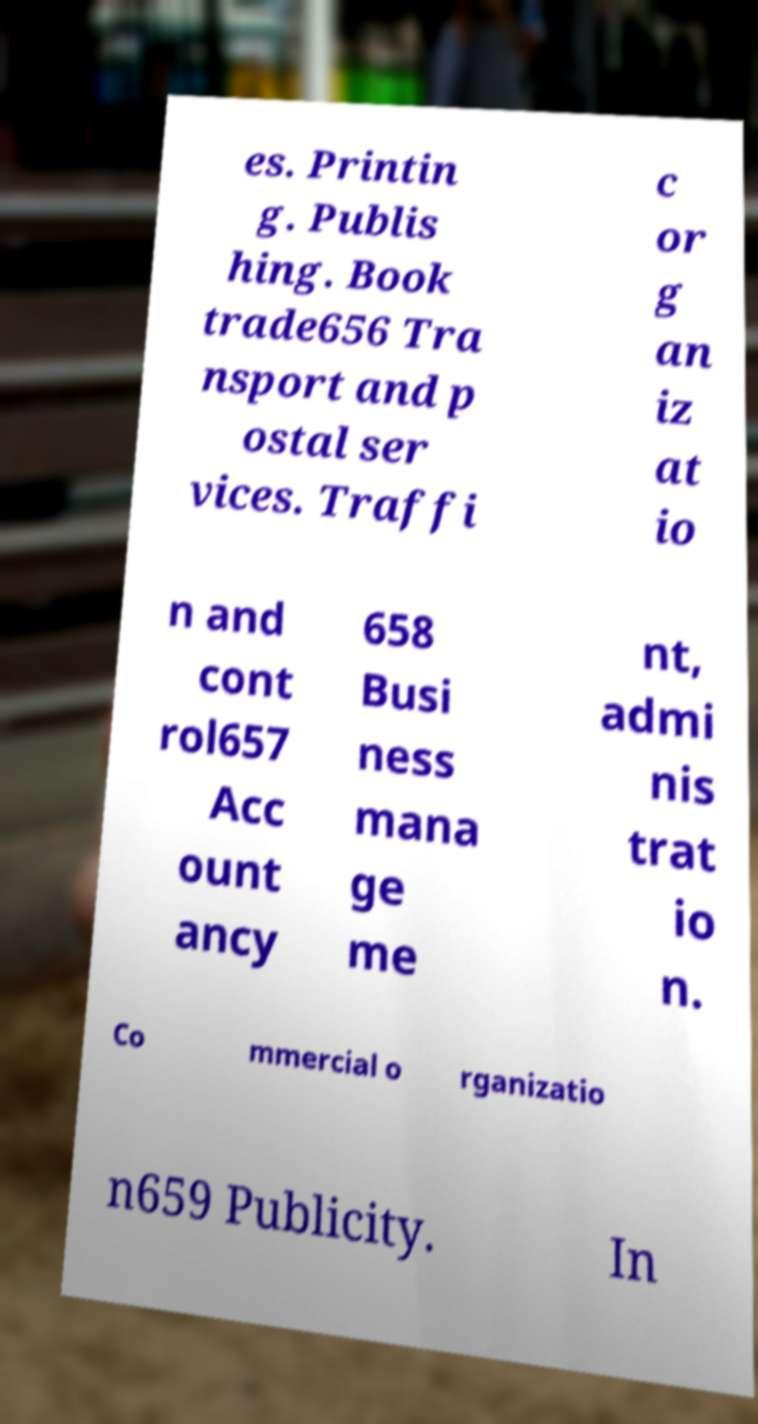Could you extract and type out the text from this image? es. Printin g. Publis hing. Book trade656 Tra nsport and p ostal ser vices. Traffi c or g an iz at io n and cont rol657 Acc ount ancy 658 Busi ness mana ge me nt, admi nis trat io n. Co mmercial o rganizatio n659 Publicity. In 